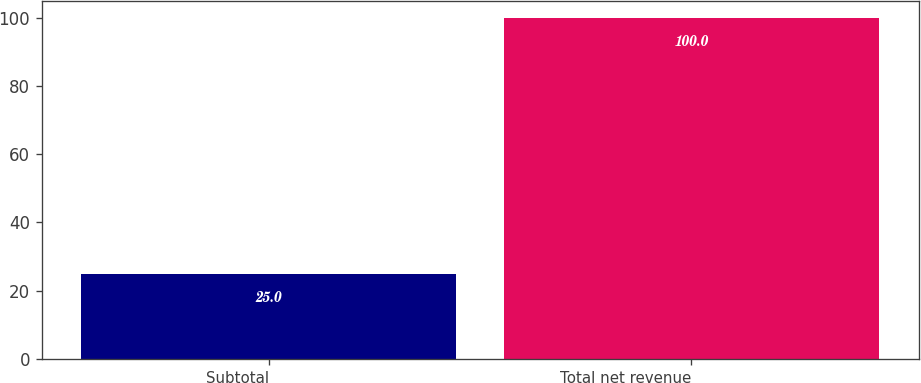<chart> <loc_0><loc_0><loc_500><loc_500><bar_chart><fcel>Subtotal<fcel>Total net revenue<nl><fcel>25<fcel>100<nl></chart> 